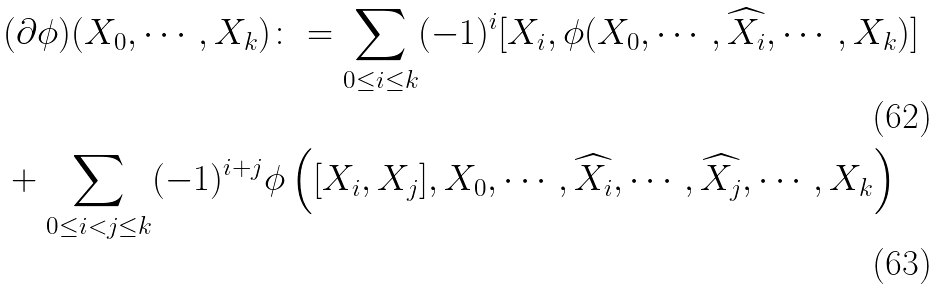<formula> <loc_0><loc_0><loc_500><loc_500>& ( \partial \phi ) ( X _ { 0 } , \cdots , X _ { k } ) \colon = \sum _ { 0 \leq i \leq k } ( - 1 ) ^ { i } [ X _ { i } , \phi ( X _ { 0 } , \cdots , \widehat { X _ { i } } , \cdots , X _ { k } ) ] \\ & + \sum _ { 0 \leq i < j \leq k } ( - 1 ) ^ { i + j } \phi \left ( [ X _ { i } , X _ { j } ] , X _ { 0 } , \cdots , \widehat { X _ { i } } , \cdots , \widehat { X _ { j } } , \cdots , X _ { k } \right )</formula> 